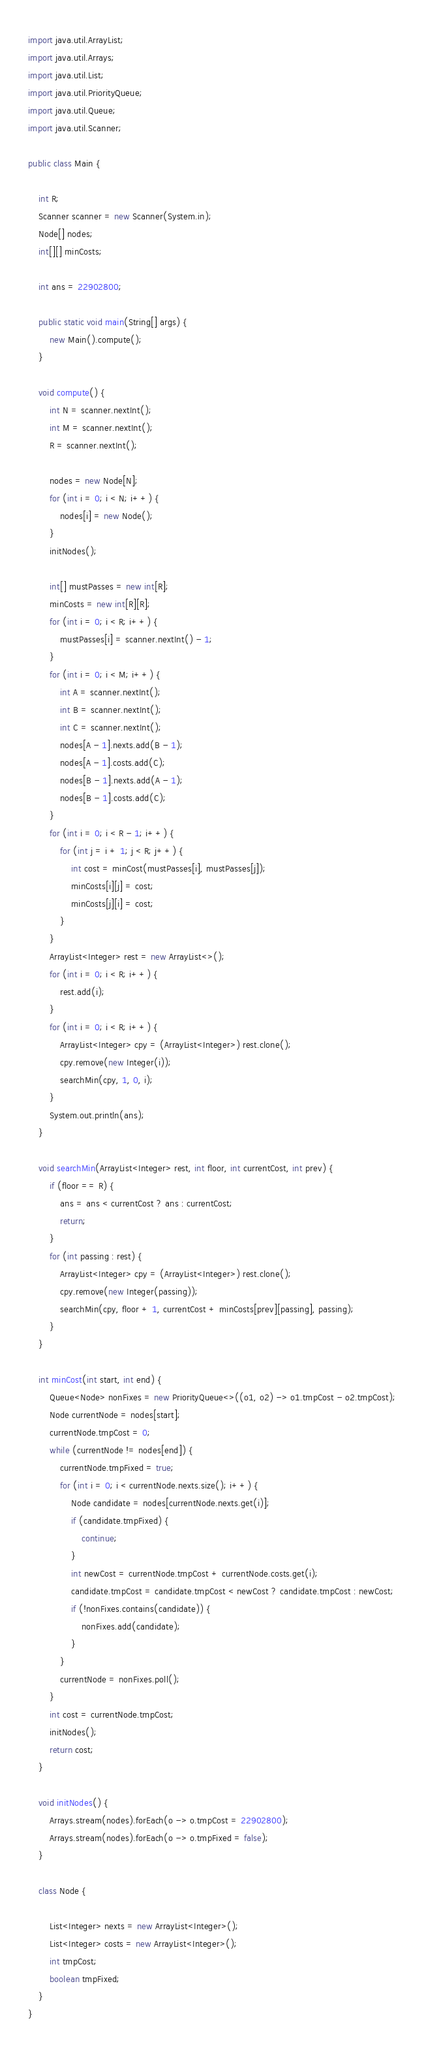Convert code to text. <code><loc_0><loc_0><loc_500><loc_500><_Java_>import java.util.ArrayList;
import java.util.Arrays;
import java.util.List;
import java.util.PriorityQueue;
import java.util.Queue;
import java.util.Scanner;

public class Main {

    int R;
    Scanner scanner = new Scanner(System.in);
    Node[] nodes;
    int[][] minCosts;

    int ans = 22902800;

    public static void main(String[] args) {
        new Main().compute();
    }

    void compute() {
        int N = scanner.nextInt();
        int M = scanner.nextInt();
        R = scanner.nextInt();

        nodes = new Node[N];
        for (int i = 0; i < N; i++) {
            nodes[i] = new Node();
        }
        initNodes();

        int[] mustPasses = new int[R];
        minCosts = new int[R][R];
        for (int i = 0; i < R; i++) {
            mustPasses[i] = scanner.nextInt() - 1;
        }
        for (int i = 0; i < M; i++) {
            int A = scanner.nextInt();
            int B = scanner.nextInt();
            int C = scanner.nextInt();
            nodes[A - 1].nexts.add(B - 1);
            nodes[A - 1].costs.add(C);
            nodes[B - 1].nexts.add(A - 1);
            nodes[B - 1].costs.add(C);
        }
        for (int i = 0; i < R - 1; i++) {
            for (int j = i + 1; j < R; j++) {
                int cost = minCost(mustPasses[i], mustPasses[j]);
                minCosts[i][j] = cost;
                minCosts[j][i] = cost;
            }
        }
        ArrayList<Integer> rest = new ArrayList<>();
        for (int i = 0; i < R; i++) {
            rest.add(i);
        }
        for (int i = 0; i < R; i++) {
            ArrayList<Integer> cpy = (ArrayList<Integer>) rest.clone();
            cpy.remove(new Integer(i));
            searchMin(cpy, 1, 0, i);
        }
        System.out.println(ans);
    }

    void searchMin(ArrayList<Integer> rest, int floor, int currentCost, int prev) {
        if (floor == R) {
            ans = ans < currentCost ? ans : currentCost;
            return;
        }
        for (int passing : rest) {
            ArrayList<Integer> cpy = (ArrayList<Integer>) rest.clone();
            cpy.remove(new Integer(passing));
            searchMin(cpy, floor + 1, currentCost + minCosts[prev][passing], passing);
        }
    }

    int minCost(int start, int end) {
        Queue<Node> nonFixes = new PriorityQueue<>((o1, o2) -> o1.tmpCost - o2.tmpCost);
        Node currentNode = nodes[start];
        currentNode.tmpCost = 0;
        while (currentNode != nodes[end]) {
            currentNode.tmpFixed = true;
            for (int i = 0; i < currentNode.nexts.size(); i++) {
                Node candidate = nodes[currentNode.nexts.get(i)];
                if (candidate.tmpFixed) {
                    continue;
                }
                int newCost = currentNode.tmpCost + currentNode.costs.get(i);
                candidate.tmpCost = candidate.tmpCost < newCost ? candidate.tmpCost : newCost;
                if (!nonFixes.contains(candidate)) {
                    nonFixes.add(candidate);
                }
            }
            currentNode = nonFixes.poll();
        }
        int cost = currentNode.tmpCost;
        initNodes();
        return cost;
    }

    void initNodes() {
        Arrays.stream(nodes).forEach(o -> o.tmpCost = 22902800);
        Arrays.stream(nodes).forEach(o -> o.tmpFixed = false);
    }

    class Node {

        List<Integer> nexts = new ArrayList<Integer>();
        List<Integer> costs = new ArrayList<Integer>();
        int tmpCost;
        boolean tmpFixed;
    }
}
</code> 